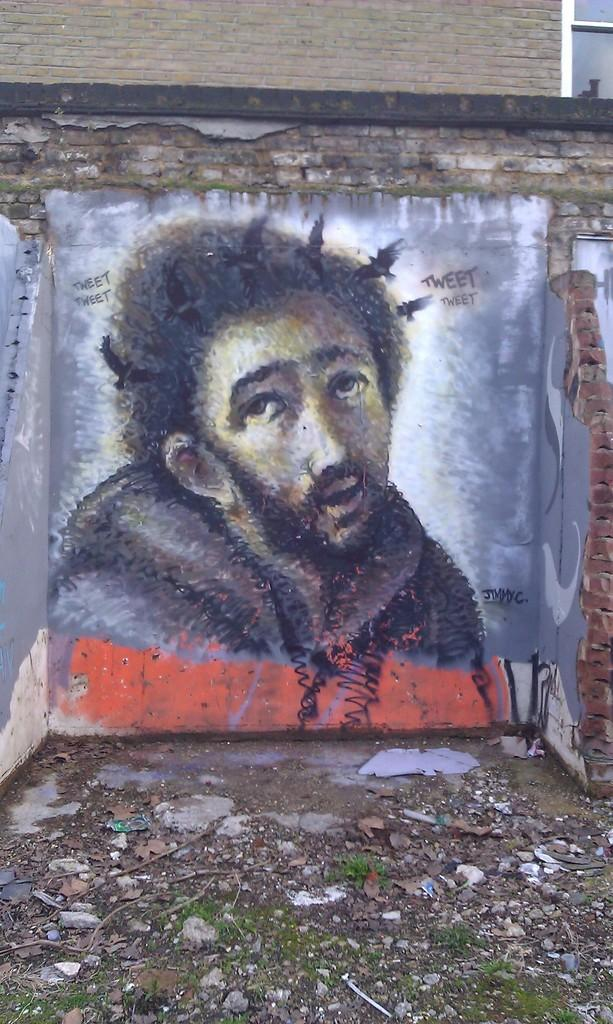What is depicted on the wall in the image? There is a person's painting on a wall in the image. What architectural feature can be seen in the image? There is a window in the image. What type of natural elements are visible in the image? There are stones and grass visible in the image. What else can be found on the surface in the image? There are other objects on the surface. What type of organization is depicted in the painting on the wall? The painting on the wall does not depict an organization; it is a person's painting. Can you see a tank in the image? There is no tank present in the image. 